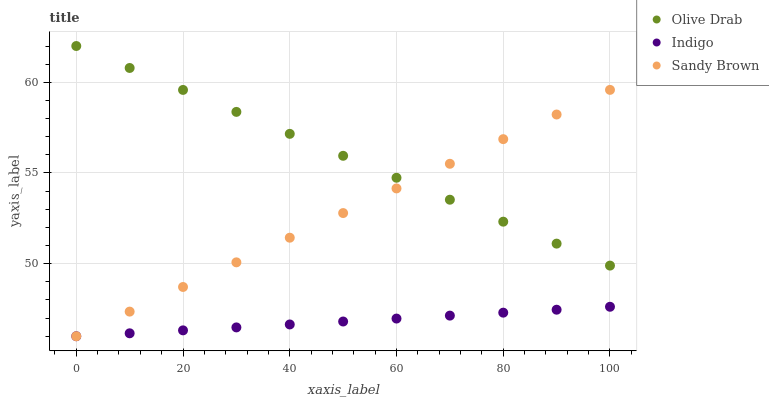Does Indigo have the minimum area under the curve?
Answer yes or no. Yes. Does Olive Drab have the maximum area under the curve?
Answer yes or no. Yes. Does Olive Drab have the minimum area under the curve?
Answer yes or no. No. Does Indigo have the maximum area under the curve?
Answer yes or no. No. Is Olive Drab the smoothest?
Answer yes or no. Yes. Is Indigo the roughest?
Answer yes or no. Yes. Is Indigo the smoothest?
Answer yes or no. No. Is Olive Drab the roughest?
Answer yes or no. No. Does Sandy Brown have the lowest value?
Answer yes or no. Yes. Does Olive Drab have the lowest value?
Answer yes or no. No. Does Olive Drab have the highest value?
Answer yes or no. Yes. Does Indigo have the highest value?
Answer yes or no. No. Is Indigo less than Olive Drab?
Answer yes or no. Yes. Is Olive Drab greater than Indigo?
Answer yes or no. Yes. Does Sandy Brown intersect Olive Drab?
Answer yes or no. Yes. Is Sandy Brown less than Olive Drab?
Answer yes or no. No. Is Sandy Brown greater than Olive Drab?
Answer yes or no. No. Does Indigo intersect Olive Drab?
Answer yes or no. No. 